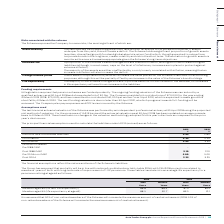Comparing values in Auto Trader's report, What is the assumed Discount rate for scheme liabilities in 2019? According to the financial document, 2.45 (percentage). The relevant text states: "Discount rate for scheme liabilities 2.45 2.60..." Also, What do the financial assumptions reflect? the nature and term of the Scheme’s liabilities. The document states: "The financial assumptions reflect the nature and term of the Scheme’s liabilities...." Also, What are the types of inflation listed in the table? The document shows two values: CPI inflation and RPI inflation. From the document: "RPI inflation 3.45 3.35 CPI inflation 2.35 2.25..." Additionally, In which year was CPI inflation percentage larger? According to the financial document, 2019. The relevant text states: "2019 % 2018 %..." Also, can you calculate: What was the change in CPI inflation percentage in 2019 from 2018? Based on the calculation: 2.35%-2.25%, the result is 0.1 (percentage). This is based on the information: "CPI inflation 2.35 2.25 CPI inflation 2.35 2.25..." The key data points involved are: 2.25, 2.35. Also, can you calculate: What was the average CPI inflation rate across 2018 and 2019? To answer this question, I need to perform calculations using the financial data. The calculation is: (2.35%+2.25%)/2, which equals 2.3 (percentage). This is based on the information: "CPI inflation 2.35 2.25 CPI inflation 2.35 2.25 CPI inflation 2.35 2.25..." The key data points involved are: 2.25, 2.35. 